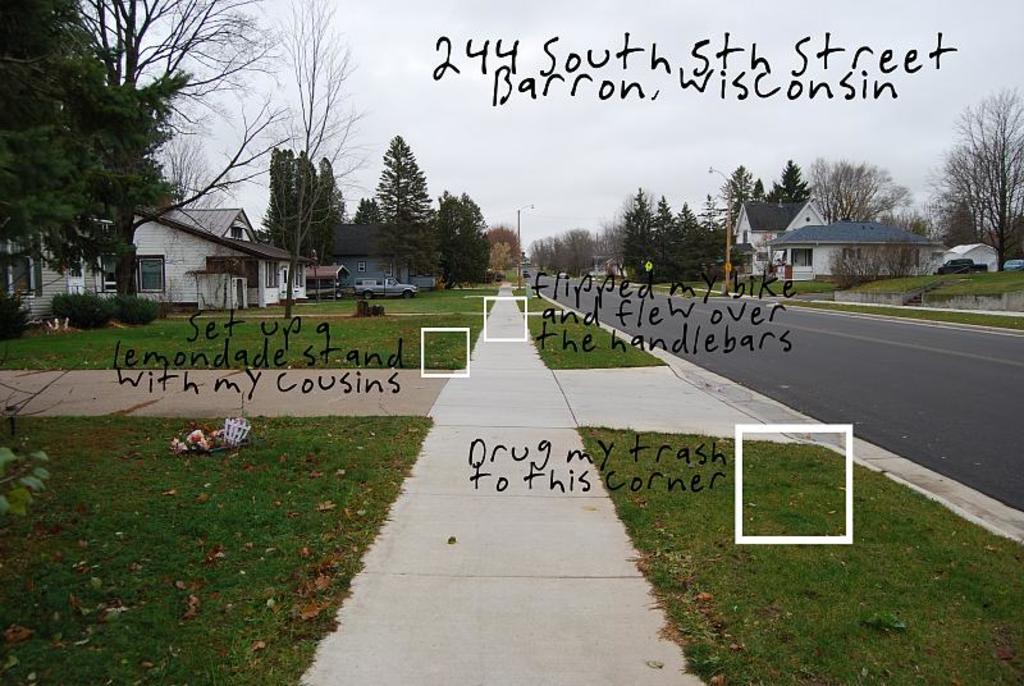How would you summarize this image in a sentence or two? In this image there is a road on the right side. There are houses on either side of the road. In front of the houses there is a garden in which there are plants and grass. There are trees in between the houses. At the top there is the sky. In the middle there is some text written on the image. 